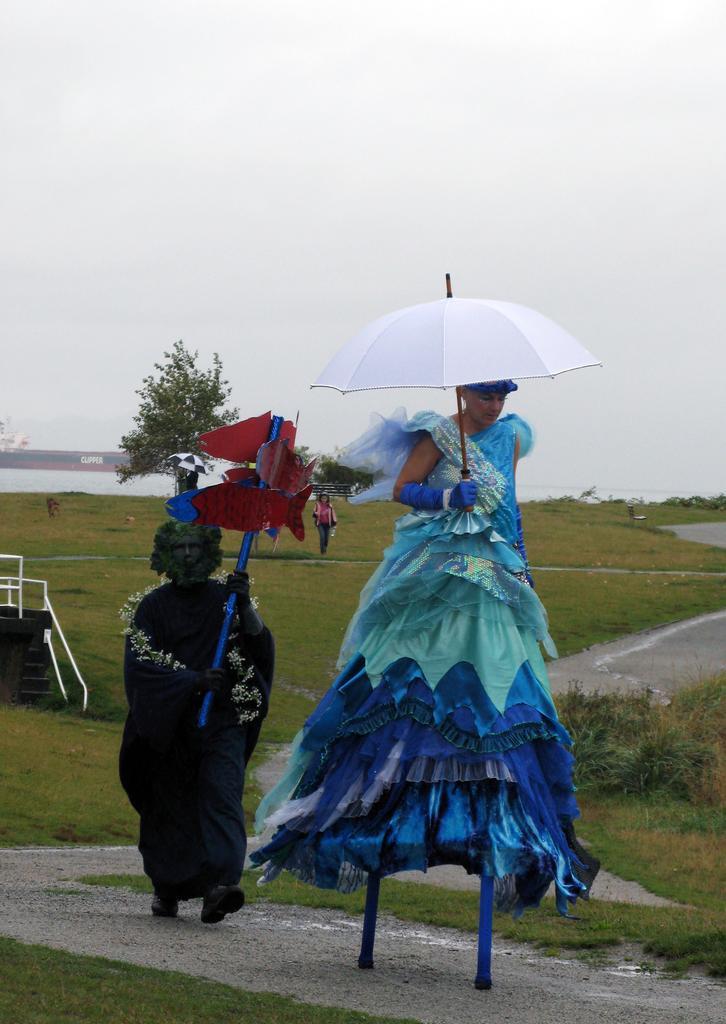Please provide a concise description of this image. The woman in blue dress who is holding a white umbrella is walking on the stand. Behind her, the man in the black dress is holding a red color thing in his hand. At the bottom of the picture, we see grass. There are trees and water in the background. At the top of the picture, we see the sky. 